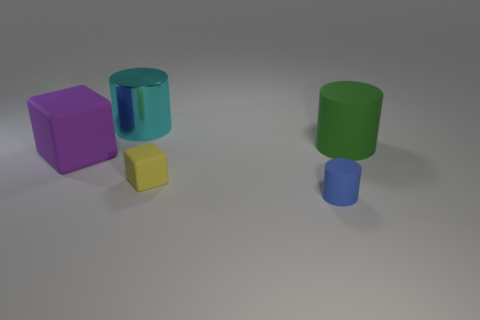Add 3 purple rubber cubes. How many objects exist? 8 Subtract all cylinders. How many objects are left? 2 Add 2 blocks. How many blocks are left? 4 Add 2 cubes. How many cubes exist? 4 Subtract 0 red blocks. How many objects are left? 5 Subtract all large brown metal cubes. Subtract all large cyan cylinders. How many objects are left? 4 